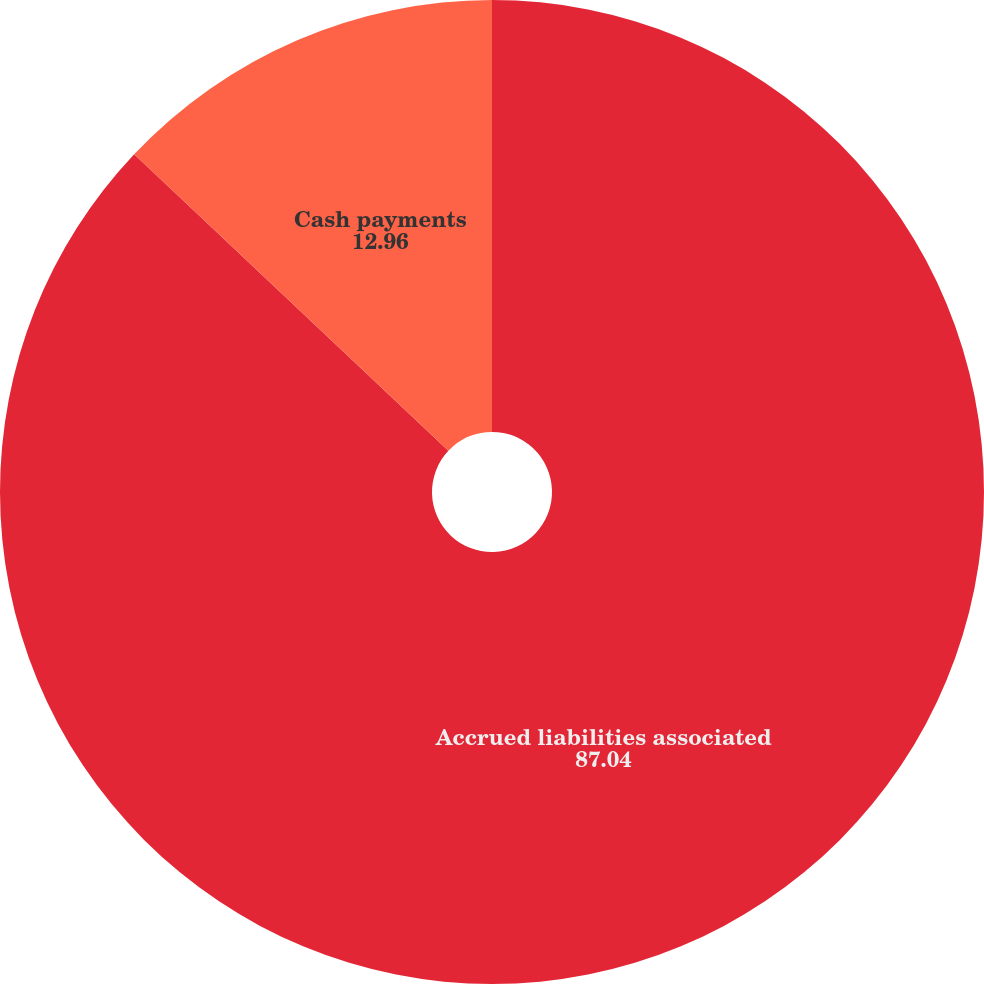<chart> <loc_0><loc_0><loc_500><loc_500><pie_chart><fcel>Accrued liabilities associated<fcel>Cash payments<nl><fcel>87.04%<fcel>12.96%<nl></chart> 